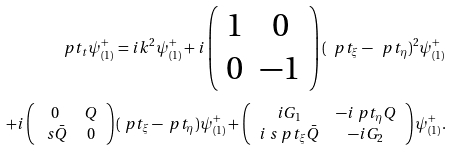<formula> <loc_0><loc_0><loc_500><loc_500>\ p t _ { t } \psi ^ { + } _ { ( 1 ) } = i k ^ { 2 } \psi ^ { + } _ { ( 1 ) } + i \left ( \begin{array} { c c } 1 & 0 \\ 0 & - 1 \end{array} \right ) ( \ p t _ { \xi } - \ p t _ { \eta } ) ^ { 2 } \psi ^ { + } _ { ( 1 ) } \\ + i \left ( \begin{array} { c c } 0 & Q \\ \ s \bar { Q } & 0 \end{array} \right ) ( \ p t _ { \xi } - \ p t _ { \eta } ) \psi ^ { + } _ { ( 1 ) } + \left ( \begin{array} { c c } i G _ { 1 } & - i \ p t _ { \eta } Q \\ i \ s \ p t _ { \xi } \bar { Q } & - i G _ { 2 } \end{array} \right ) \psi ^ { + } _ { ( 1 ) } .</formula> 